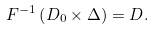Convert formula to latex. <formula><loc_0><loc_0><loc_500><loc_500>F ^ { - 1 } \left ( D _ { 0 } \times \Delta \right ) = D .</formula> 